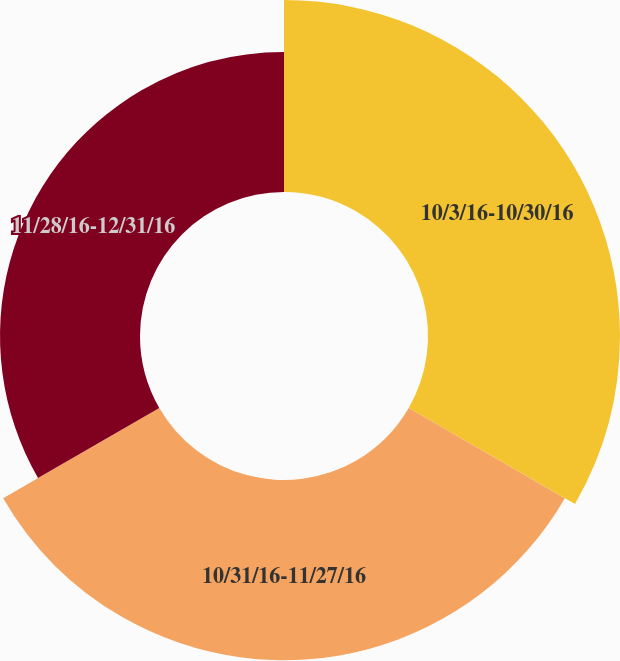Convert chart. <chart><loc_0><loc_0><loc_500><loc_500><pie_chart><fcel>10/3/16-10/30/16<fcel>10/31/16-11/27/16<fcel>11/28/16-12/31/16<nl><fcel>37.48%<fcel>35.19%<fcel>27.33%<nl></chart> 